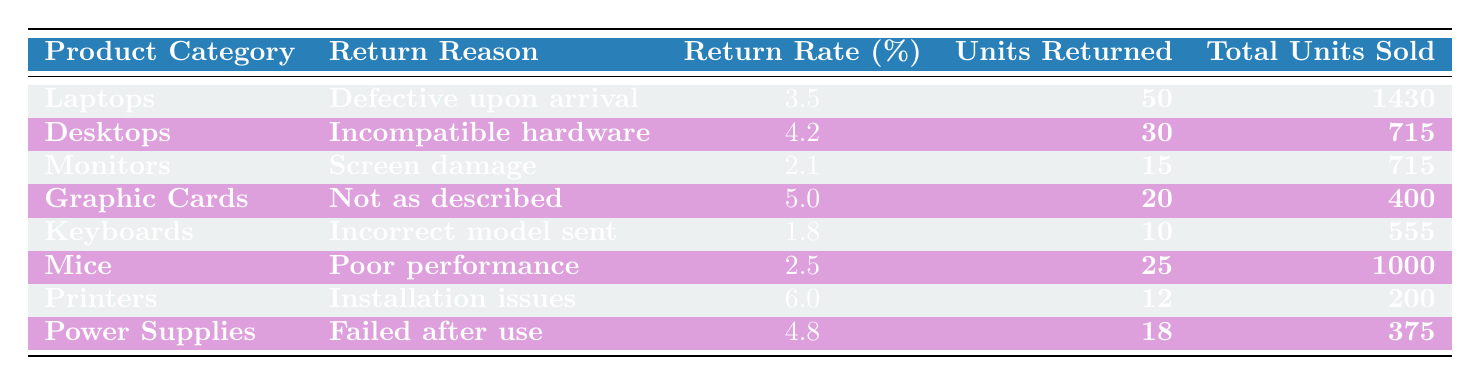What is the return rate for Laptops due to being defective upon arrival? According to the table, Laptops have a return rate of 3.5% for the reason "Defective upon arrival."
Answer: 3.5% Which product category has the highest return rate and what is that rate? By examining the return rates, Printers have the highest return rate at 6.0%.
Answer: Printers, 6.0% How many units of Desktops were returned due to incompatible hardware? The table specifies that 30 units of Desktops were returned for the reason of incompatible hardware.
Answer: 30 Is the return rate for Mice higher than that of Keyboards? Mice have a return rate of 2.5% and Keyboards have a return rate of 1.8%. Since 2.5% > 1.8%, the statement is true.
Answer: Yes What is the average return rate for all product categories listed in the table? To calculate the average, sum the return rates: (3.5 + 4.2 + 2.1 + 5.0 + 1.8 + 2.5 + 6.0 + 4.8) / 8 = 3.4. Thus, the average return rate is 3.4%.
Answer: 3.4% What is the total number of units returned across all product categories? The total units returned is found by summing the units returned for each category: 50 + 30 + 15 + 20 + 10 + 25 + 12 + 18 = 180.
Answer: 180 Which product category experienced return issues due to installation problems? According to the table, the product category that faced installation issues is Printers.
Answer: Printers Are more units of Graphic Cards returned due to being not as described than units of Keyboards returned due to incorrect models sent? Graphic Cards had 20 units returned while Keyboards had 10 units returned. Since 20 > 10, the statement is true.
Answer: Yes How many more units of Power Supplies were returned compared to Monitors? Power Supplies had 18 units returned and Monitors had 15 units returned. The difference in units returned is 18 - 15 = 3.
Answer: 3 